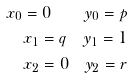<formula> <loc_0><loc_0><loc_500><loc_500>x _ { 0 } = 0 \quad y _ { 0 } = p \\ x _ { 1 } = q \quad y _ { 1 } = 1 \\ x _ { 2 } = 0 \quad y _ { 2 } = r</formula> 